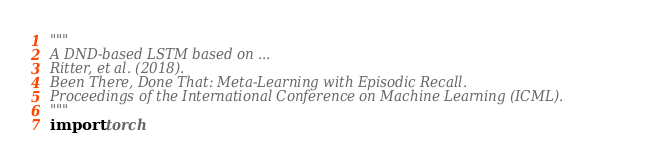<code> <loc_0><loc_0><loc_500><loc_500><_Python_>"""
A DND-based LSTM based on ...
Ritter, et al. (2018).
Been There, Done That: Meta-Learning with Episodic Recall.
Proceedings of the International Conference on Machine Learning (ICML).
"""
import torch</code> 